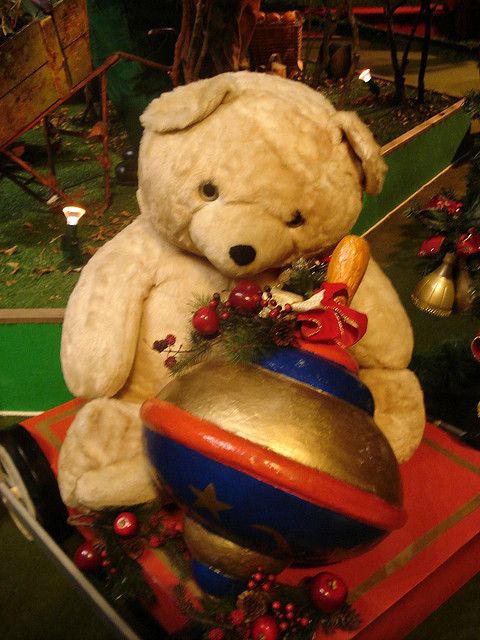What can you tell me about the bear's appearance? This is a plush teddy bear with a cream-colored fur. It has a thoughtful expression with its head slightly tilted to the side, contributing to its endearing charm. It is adorned with a sprig of holly and berries, which adds to the overall holiday theme of its setting. 